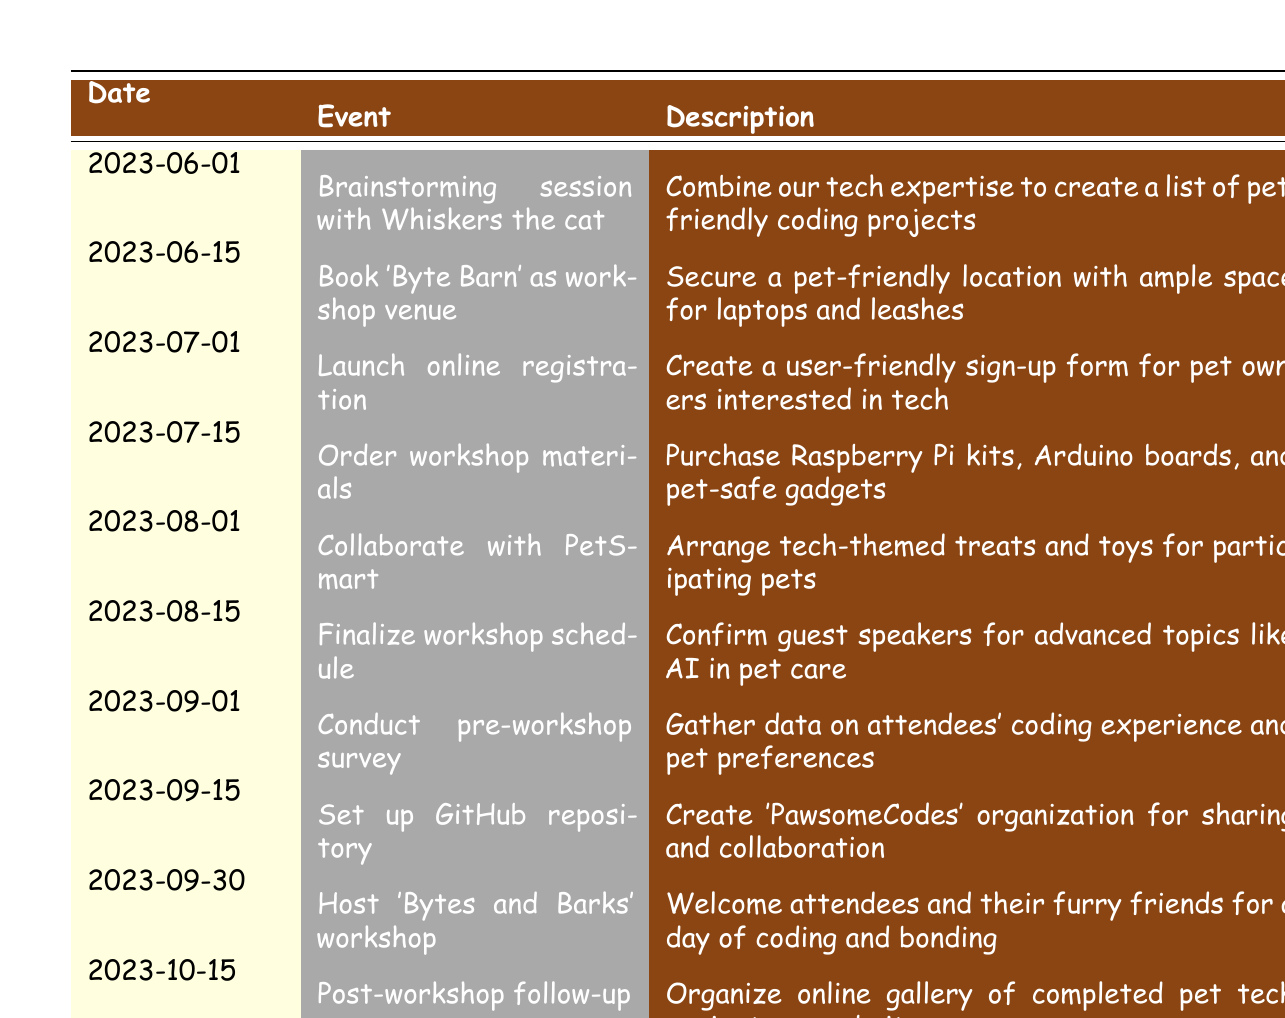What event occurred on June 15, 2023? The table provides the event details for June 15, 2023. It lists "Book 'Byte Barn' as workshop venue" as the event for that date.
Answer: Book 'Byte Barn' as workshop venue How many days are there between the brainstorming session and the workshop date? The brainstorming session occurred on June 1, 2023, and the workshop date was September 30, 2023. The number of days between these two dates is 120 days.
Answer: 120 days Did PetSmart sponsor the workshop? The table indicates that on August 1, 2023, there was indeed a collaboration with PetSmart for goodie bag sponsorship. Thus, the answer is yes.
Answer: Yes What were the events leading up to the workshop on September 30? To identify events leading up to the workshop, we filter the date range from June 1 to September 30, 2023. The relevant events are: brainstorming session, booking the venue, launching registration, ordering materials, collaborating with PetSmart, finalizing the schedule, conducting the survey, and setting up the GitHub repository.
Answer: Seven events How many days after the finalization of the schedule was the workshop conducted? The schedule was finalized on August 15, 2023, and the workshop took place on September 30, 2023. The difference is 46 days from finalization to the workshop date.
Answer: 46 days Was there any event related to gathering data on attendees' preferences? The table notes that on September 1, 2023, a pre-workshop survey was conducted to gather data on attendees' coding experience and pet preferences. Therefore, the answer is yes.
Answer: Yes What is the total number of events listed in the table? The table contains a total of 10 distinct events related to organizing the workshop, as each entry from June to October 2023 describes a key event.
Answer: 10 events What was the latest event before hosting the workshop? The latest event before hosting the workshop on September 30, 2023, is the GitHub repository setup on September 15, 2023. We confirm this by checking the date of each event listed.
Answer: Set up GitHub repository What type of materials were ordered for the workshop? The August 15, 2023 entry specifies that workshop materials included Raspberry Pi kits, Arduino boards, and pet-safe gadgets.
Answer: Raspberry Pi kits, Arduino boards, pet-safe gadgets 